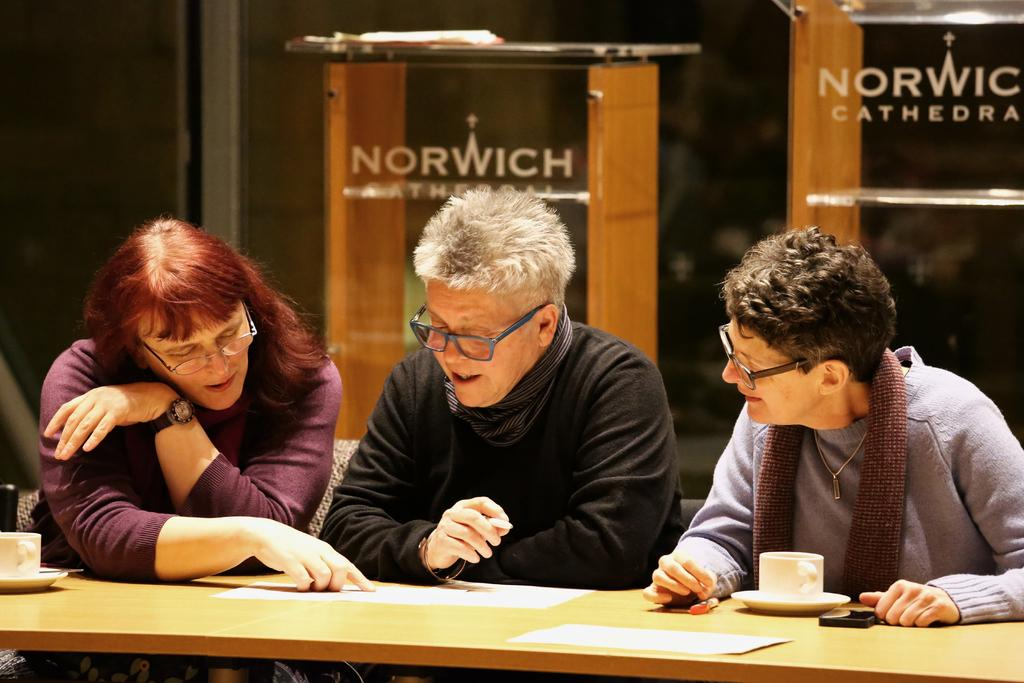How many people are in the image? There are three people in the image. What are the people doing in the image? The people are near a table. What can be observed about the people's appearance? The people are wearing spectacles. What items are on the table in the image? There are cups, saucers, papers, and a mobile on the table. What is visible in the background of the image? There are podiums in the background of the image. What type of bread is being distributed by the doll in the image? There is no doll or bread present in the image. 